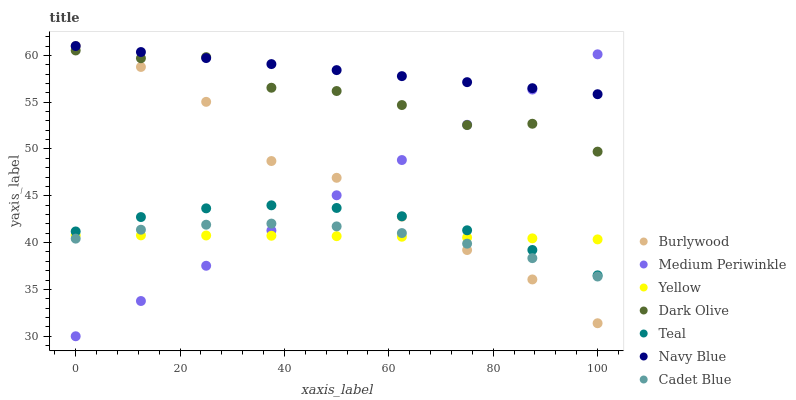Does Cadet Blue have the minimum area under the curve?
Answer yes or no. Yes. Does Navy Blue have the maximum area under the curve?
Answer yes or no. Yes. Does Burlywood have the minimum area under the curve?
Answer yes or no. No. Does Burlywood have the maximum area under the curve?
Answer yes or no. No. Is Navy Blue the smoothest?
Answer yes or no. Yes. Is Dark Olive the roughest?
Answer yes or no. Yes. Is Burlywood the smoothest?
Answer yes or no. No. Is Burlywood the roughest?
Answer yes or no. No. Does Medium Periwinkle have the lowest value?
Answer yes or no. Yes. Does Burlywood have the lowest value?
Answer yes or no. No. Does Navy Blue have the highest value?
Answer yes or no. Yes. Does Dark Olive have the highest value?
Answer yes or no. No. Is Teal less than Navy Blue?
Answer yes or no. Yes. Is Dark Olive greater than Teal?
Answer yes or no. Yes. Does Medium Periwinkle intersect Burlywood?
Answer yes or no. Yes. Is Medium Periwinkle less than Burlywood?
Answer yes or no. No. Is Medium Periwinkle greater than Burlywood?
Answer yes or no. No. Does Teal intersect Navy Blue?
Answer yes or no. No. 